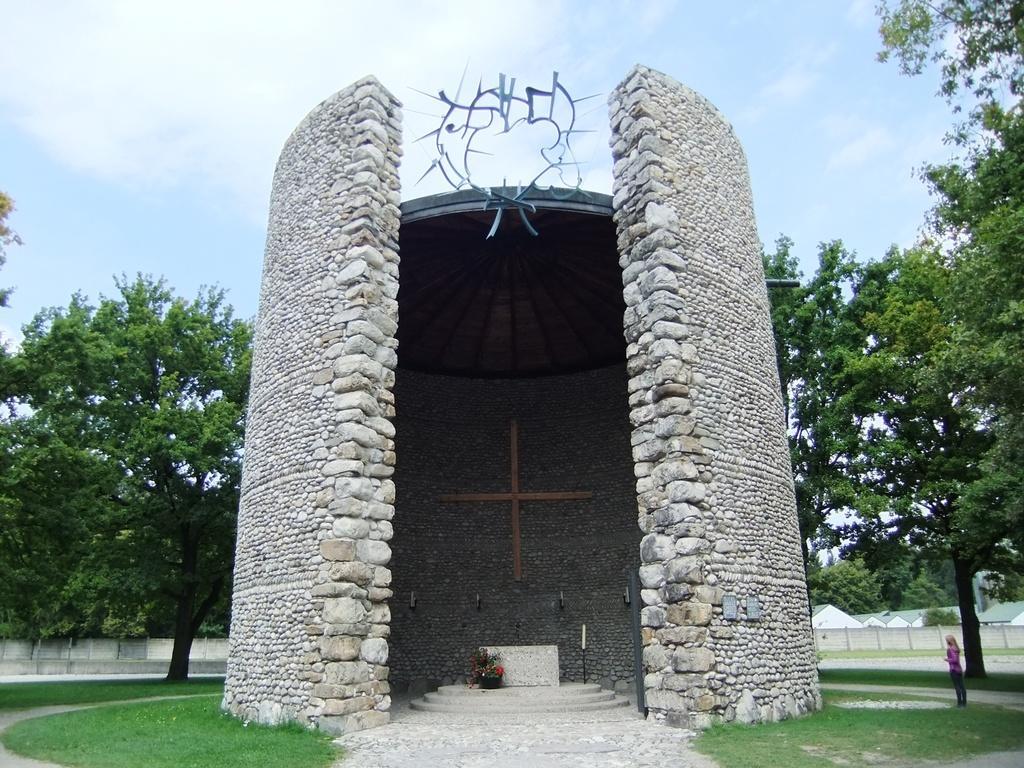Can you describe this image briefly? In this image we can see a stone constructed circular wall, a person is sitting inside it and it is surrounded by grass and trees, on the bottom right corner of the image a person is standing and in the background there are houses. 